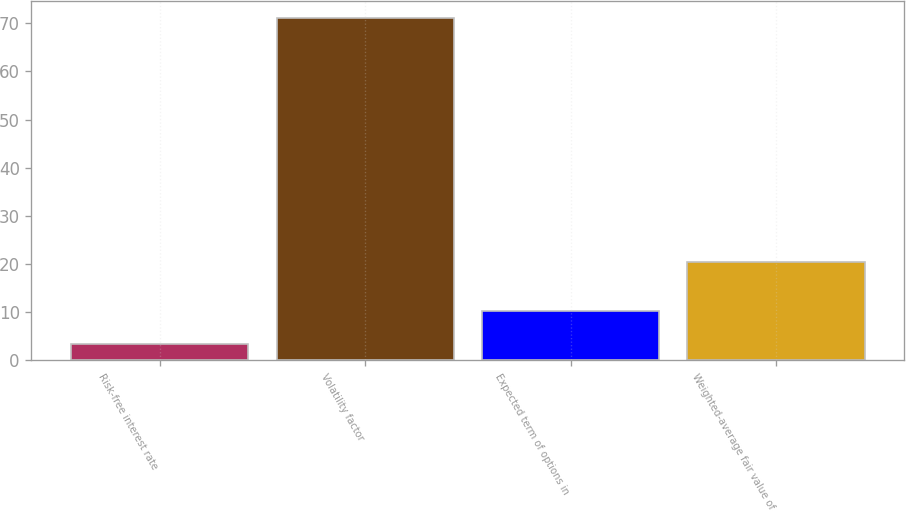Convert chart. <chart><loc_0><loc_0><loc_500><loc_500><bar_chart><fcel>Risk-free interest rate<fcel>Volatility factor<fcel>Expected term of options in<fcel>Weighted-average fair value of<nl><fcel>3.32<fcel>71.08<fcel>10.1<fcel>20.38<nl></chart> 